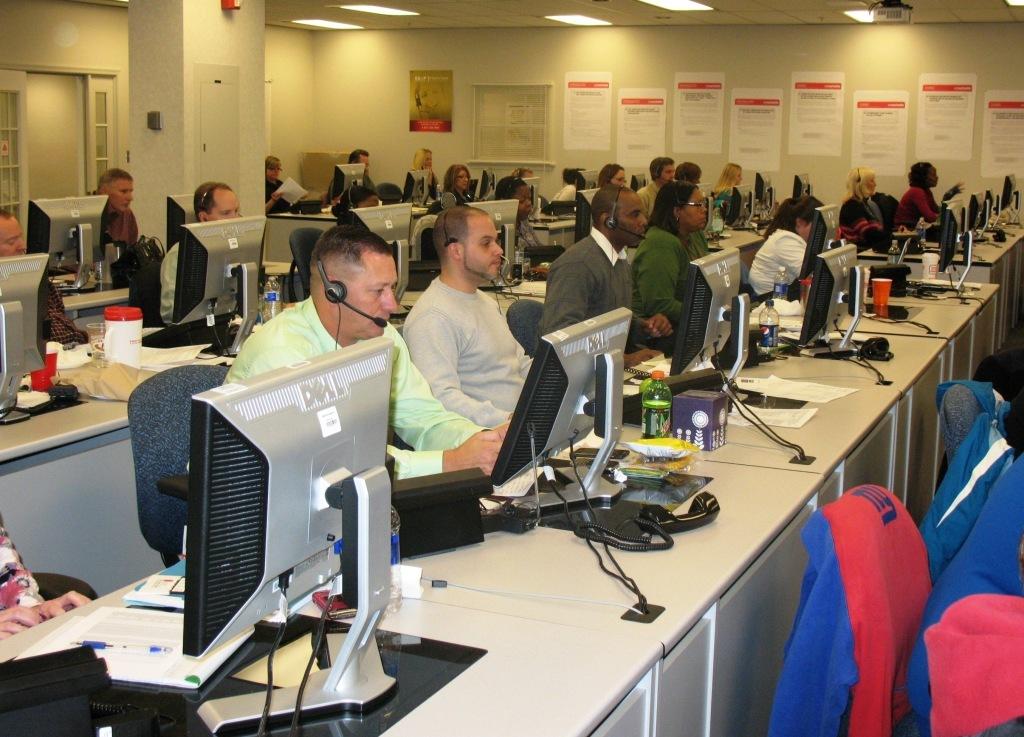What brand are the monitors at this workspace?
Offer a terse response. Dell. What type of pc are they using?
Offer a terse response. Dell. 